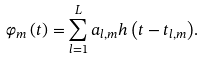Convert formula to latex. <formula><loc_0><loc_0><loc_500><loc_500>\varphi _ { m } \left ( t \right ) = \sum _ { l = 1 } ^ { L } { a _ { l , m } h \left ( t - t _ { l , m } \right ) } .</formula> 